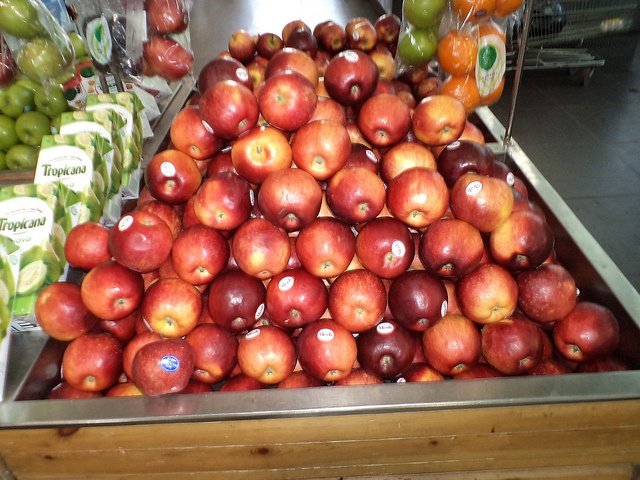Describe the objects in this image and their specific colors. I can see apple in olive, brown, maroon, and salmon tones, orange in olive, red, brown, and orange tones, orange in olive, red, brown, and tan tones, orange in olive, brown, red, and maroon tones, and orange in olive, brown, salmon, and tan tones in this image. 